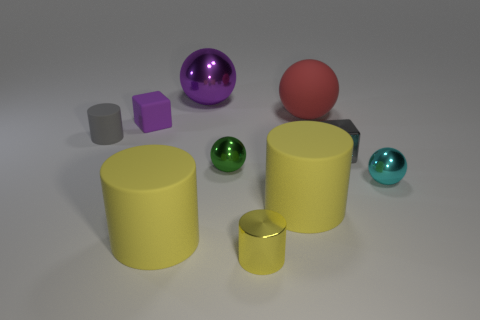Subtract all red spheres. How many yellow cylinders are left? 3 Subtract 1 spheres. How many spheres are left? 3 Subtract all gray cylinders. How many cylinders are left? 3 Subtract all spheres. How many objects are left? 6 Subtract all small metallic objects. Subtract all shiny cylinders. How many objects are left? 5 Add 3 large red rubber things. How many large red rubber things are left? 4 Add 5 red rubber balls. How many red rubber balls exist? 6 Subtract 0 green cylinders. How many objects are left? 10 